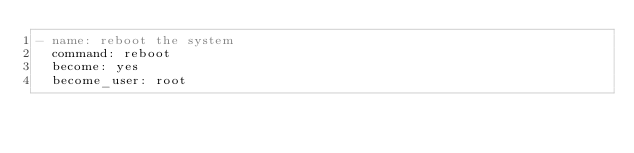Convert code to text. <code><loc_0><loc_0><loc_500><loc_500><_YAML_>- name: reboot the system
  command: reboot
  become: yes
  become_user: root</code> 